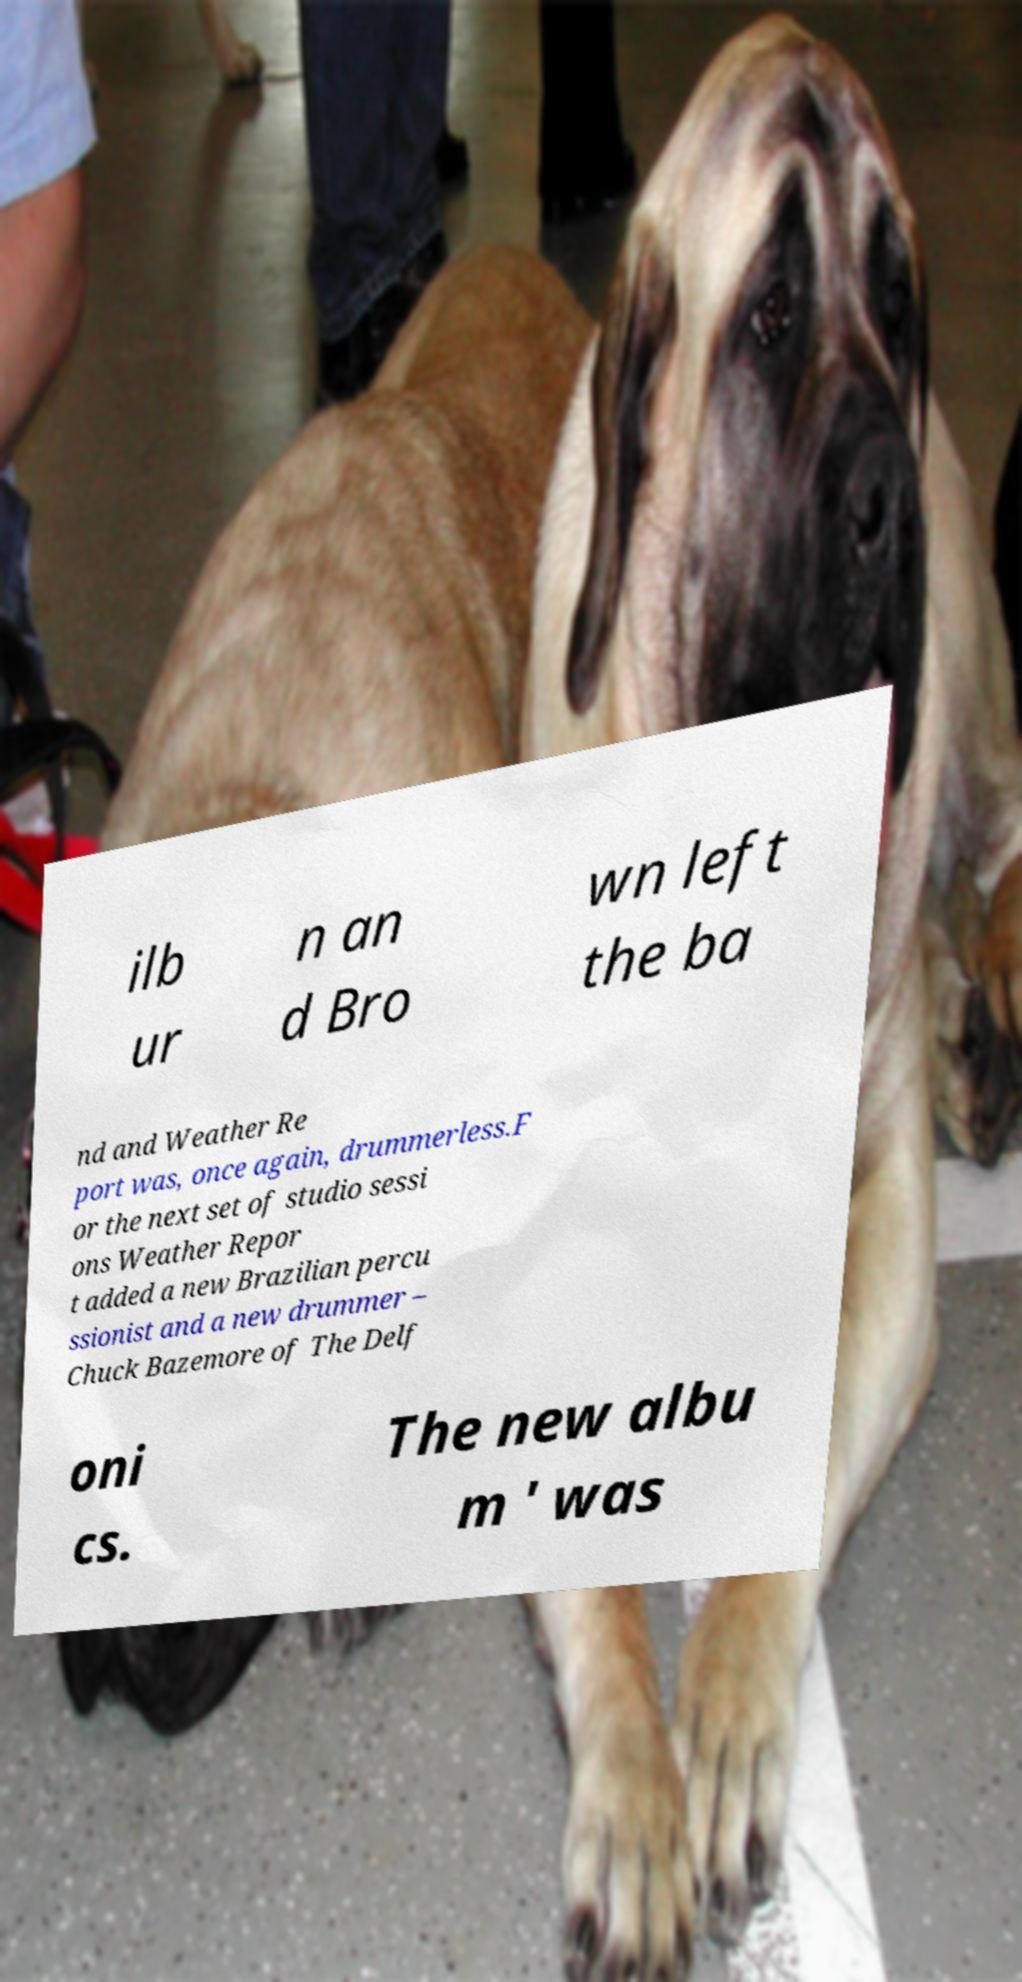Please read and relay the text visible in this image. What does it say? ilb ur n an d Bro wn left the ba nd and Weather Re port was, once again, drummerless.F or the next set of studio sessi ons Weather Repor t added a new Brazilian percu ssionist and a new drummer – Chuck Bazemore of The Delf oni cs. The new albu m ' was 